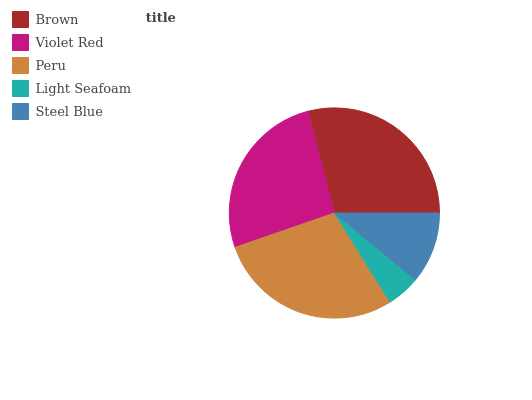Is Light Seafoam the minimum?
Answer yes or no. Yes. Is Brown the maximum?
Answer yes or no. Yes. Is Violet Red the minimum?
Answer yes or no. No. Is Violet Red the maximum?
Answer yes or no. No. Is Brown greater than Violet Red?
Answer yes or no. Yes. Is Violet Red less than Brown?
Answer yes or no. Yes. Is Violet Red greater than Brown?
Answer yes or no. No. Is Brown less than Violet Red?
Answer yes or no. No. Is Violet Red the high median?
Answer yes or no. Yes. Is Violet Red the low median?
Answer yes or no. Yes. Is Brown the high median?
Answer yes or no. No. Is Brown the low median?
Answer yes or no. No. 